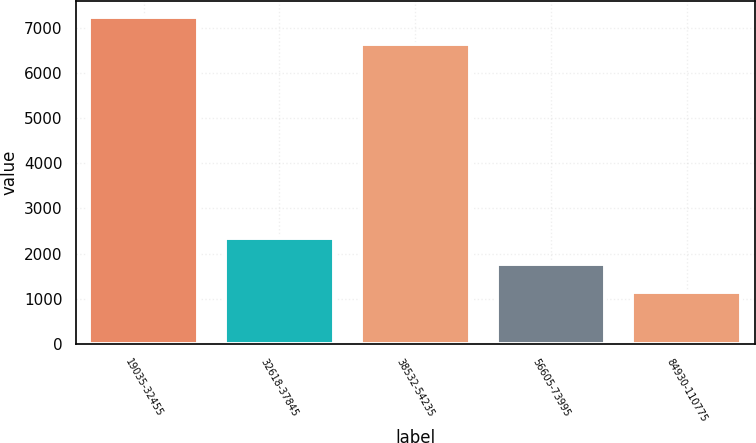<chart> <loc_0><loc_0><loc_500><loc_500><bar_chart><fcel>19035-32455<fcel>32618-37845<fcel>38532-54235<fcel>56605-73995<fcel>84930-110775<nl><fcel>7236.8<fcel>2349.8<fcel>6644<fcel>1757<fcel>1153<nl></chart> 